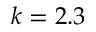<formula> <loc_0><loc_0><loc_500><loc_500>k = 2 . 3</formula> 